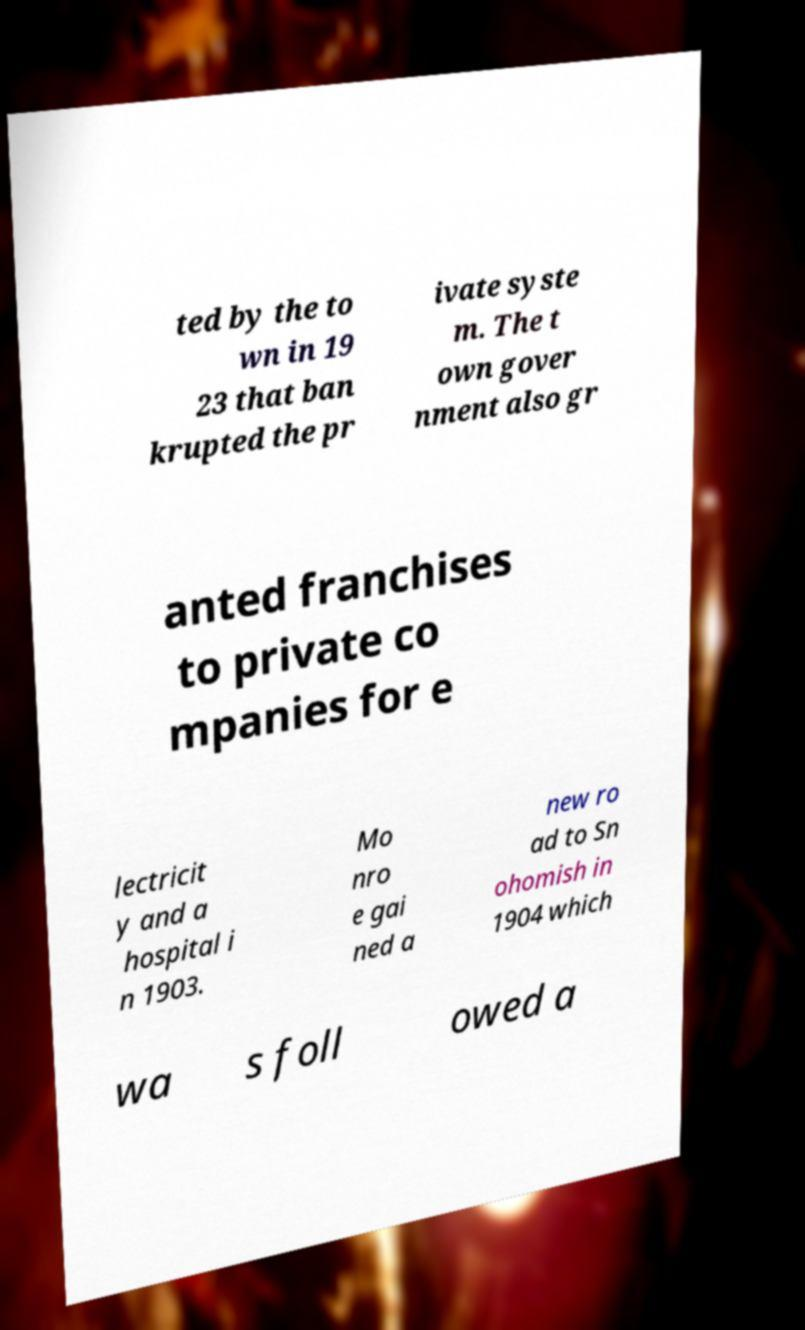For documentation purposes, I need the text within this image transcribed. Could you provide that? ted by the to wn in 19 23 that ban krupted the pr ivate syste m. The t own gover nment also gr anted franchises to private co mpanies for e lectricit y and a hospital i n 1903. Mo nro e gai ned a new ro ad to Sn ohomish in 1904 which wa s foll owed a 